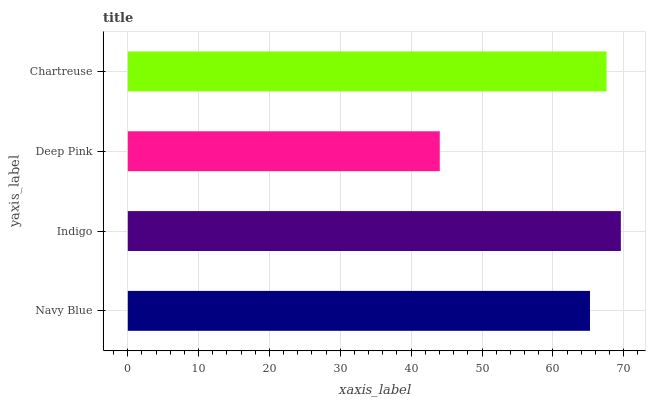Is Deep Pink the minimum?
Answer yes or no. Yes. Is Indigo the maximum?
Answer yes or no. Yes. Is Indigo the minimum?
Answer yes or no. No. Is Deep Pink the maximum?
Answer yes or no. No. Is Indigo greater than Deep Pink?
Answer yes or no. Yes. Is Deep Pink less than Indigo?
Answer yes or no. Yes. Is Deep Pink greater than Indigo?
Answer yes or no. No. Is Indigo less than Deep Pink?
Answer yes or no. No. Is Chartreuse the high median?
Answer yes or no. Yes. Is Navy Blue the low median?
Answer yes or no. Yes. Is Indigo the high median?
Answer yes or no. No. Is Chartreuse the low median?
Answer yes or no. No. 